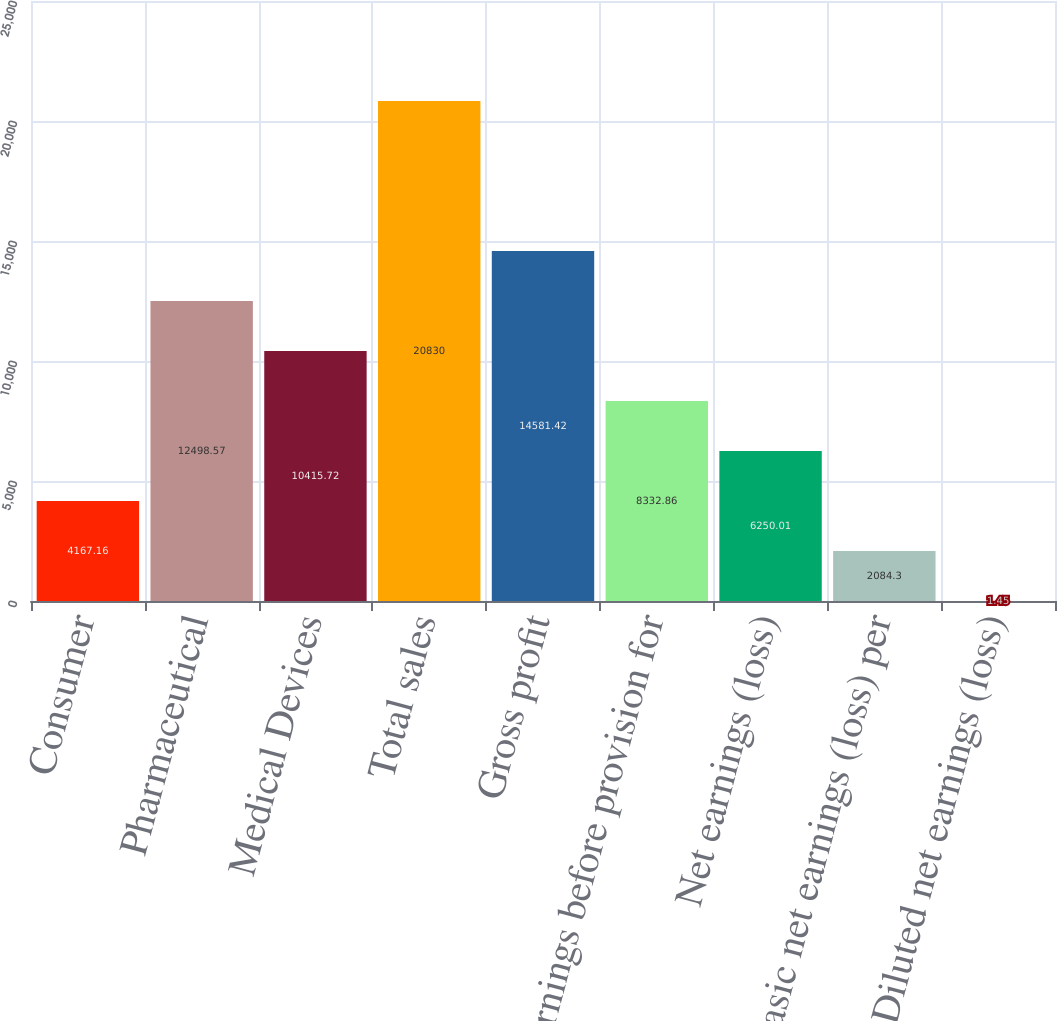Convert chart. <chart><loc_0><loc_0><loc_500><loc_500><bar_chart><fcel>Consumer<fcel>Pharmaceutical<fcel>Medical Devices<fcel>Total sales<fcel>Gross profit<fcel>Earnings before provision for<fcel>Net earnings (loss)<fcel>Basic net earnings (loss) per<fcel>Diluted net earnings (loss)<nl><fcel>4167.16<fcel>12498.6<fcel>10415.7<fcel>20830<fcel>14581.4<fcel>8332.86<fcel>6250.01<fcel>2084.3<fcel>1.45<nl></chart> 